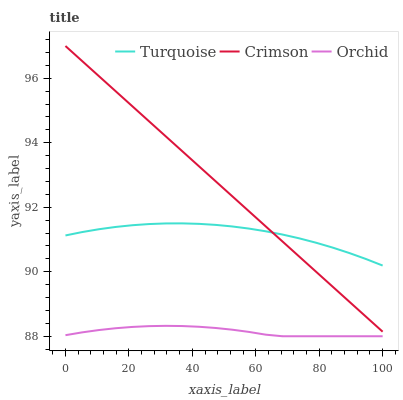Does Turquoise have the minimum area under the curve?
Answer yes or no. No. Does Turquoise have the maximum area under the curve?
Answer yes or no. No. Is Orchid the smoothest?
Answer yes or no. No. Is Orchid the roughest?
Answer yes or no. No. Does Turquoise have the lowest value?
Answer yes or no. No. Does Turquoise have the highest value?
Answer yes or no. No. Is Orchid less than Turquoise?
Answer yes or no. Yes. Is Turquoise greater than Orchid?
Answer yes or no. Yes. Does Orchid intersect Turquoise?
Answer yes or no. No. 